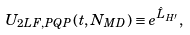Convert formula to latex. <formula><loc_0><loc_0><loc_500><loc_500>U _ { 2 L F , P Q P } ( t , N _ { M D } ) \equiv e ^ { \hat { L } _ { H ^ { \prime } } } ,</formula> 